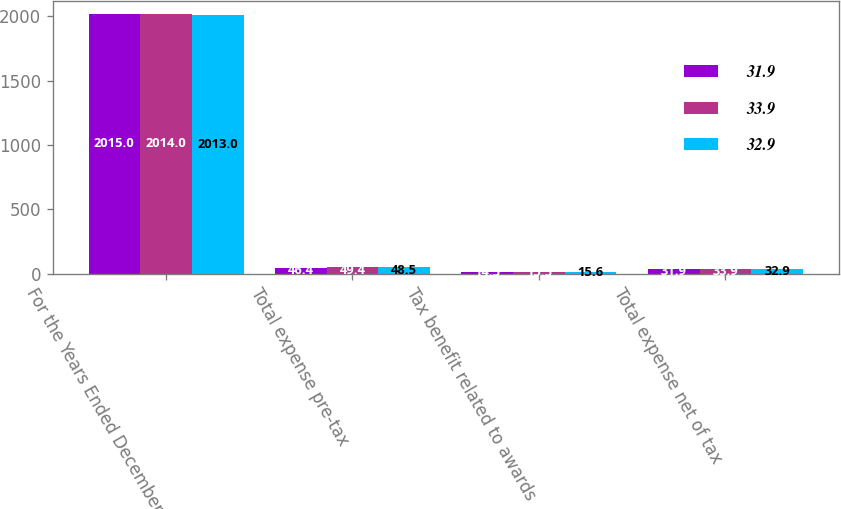Convert chart to OTSL. <chart><loc_0><loc_0><loc_500><loc_500><stacked_bar_chart><ecel><fcel>For the Years Ended December<fcel>Total expense pre-tax<fcel>Tax benefit related to awards<fcel>Total expense net of tax<nl><fcel>31.9<fcel>2015<fcel>46.4<fcel>14.5<fcel>31.9<nl><fcel>33.9<fcel>2014<fcel>49.4<fcel>15.5<fcel>33.9<nl><fcel>32.9<fcel>2013<fcel>48.5<fcel>15.6<fcel>32.9<nl></chart> 